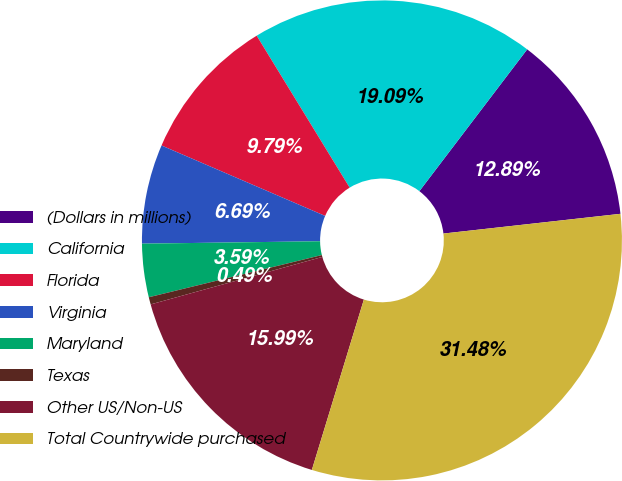Convert chart to OTSL. <chart><loc_0><loc_0><loc_500><loc_500><pie_chart><fcel>(Dollars in millions)<fcel>California<fcel>Florida<fcel>Virginia<fcel>Maryland<fcel>Texas<fcel>Other US/Non-US<fcel>Total Countrywide purchased<nl><fcel>12.89%<fcel>19.09%<fcel>9.79%<fcel>6.69%<fcel>3.59%<fcel>0.49%<fcel>15.99%<fcel>31.49%<nl></chart> 